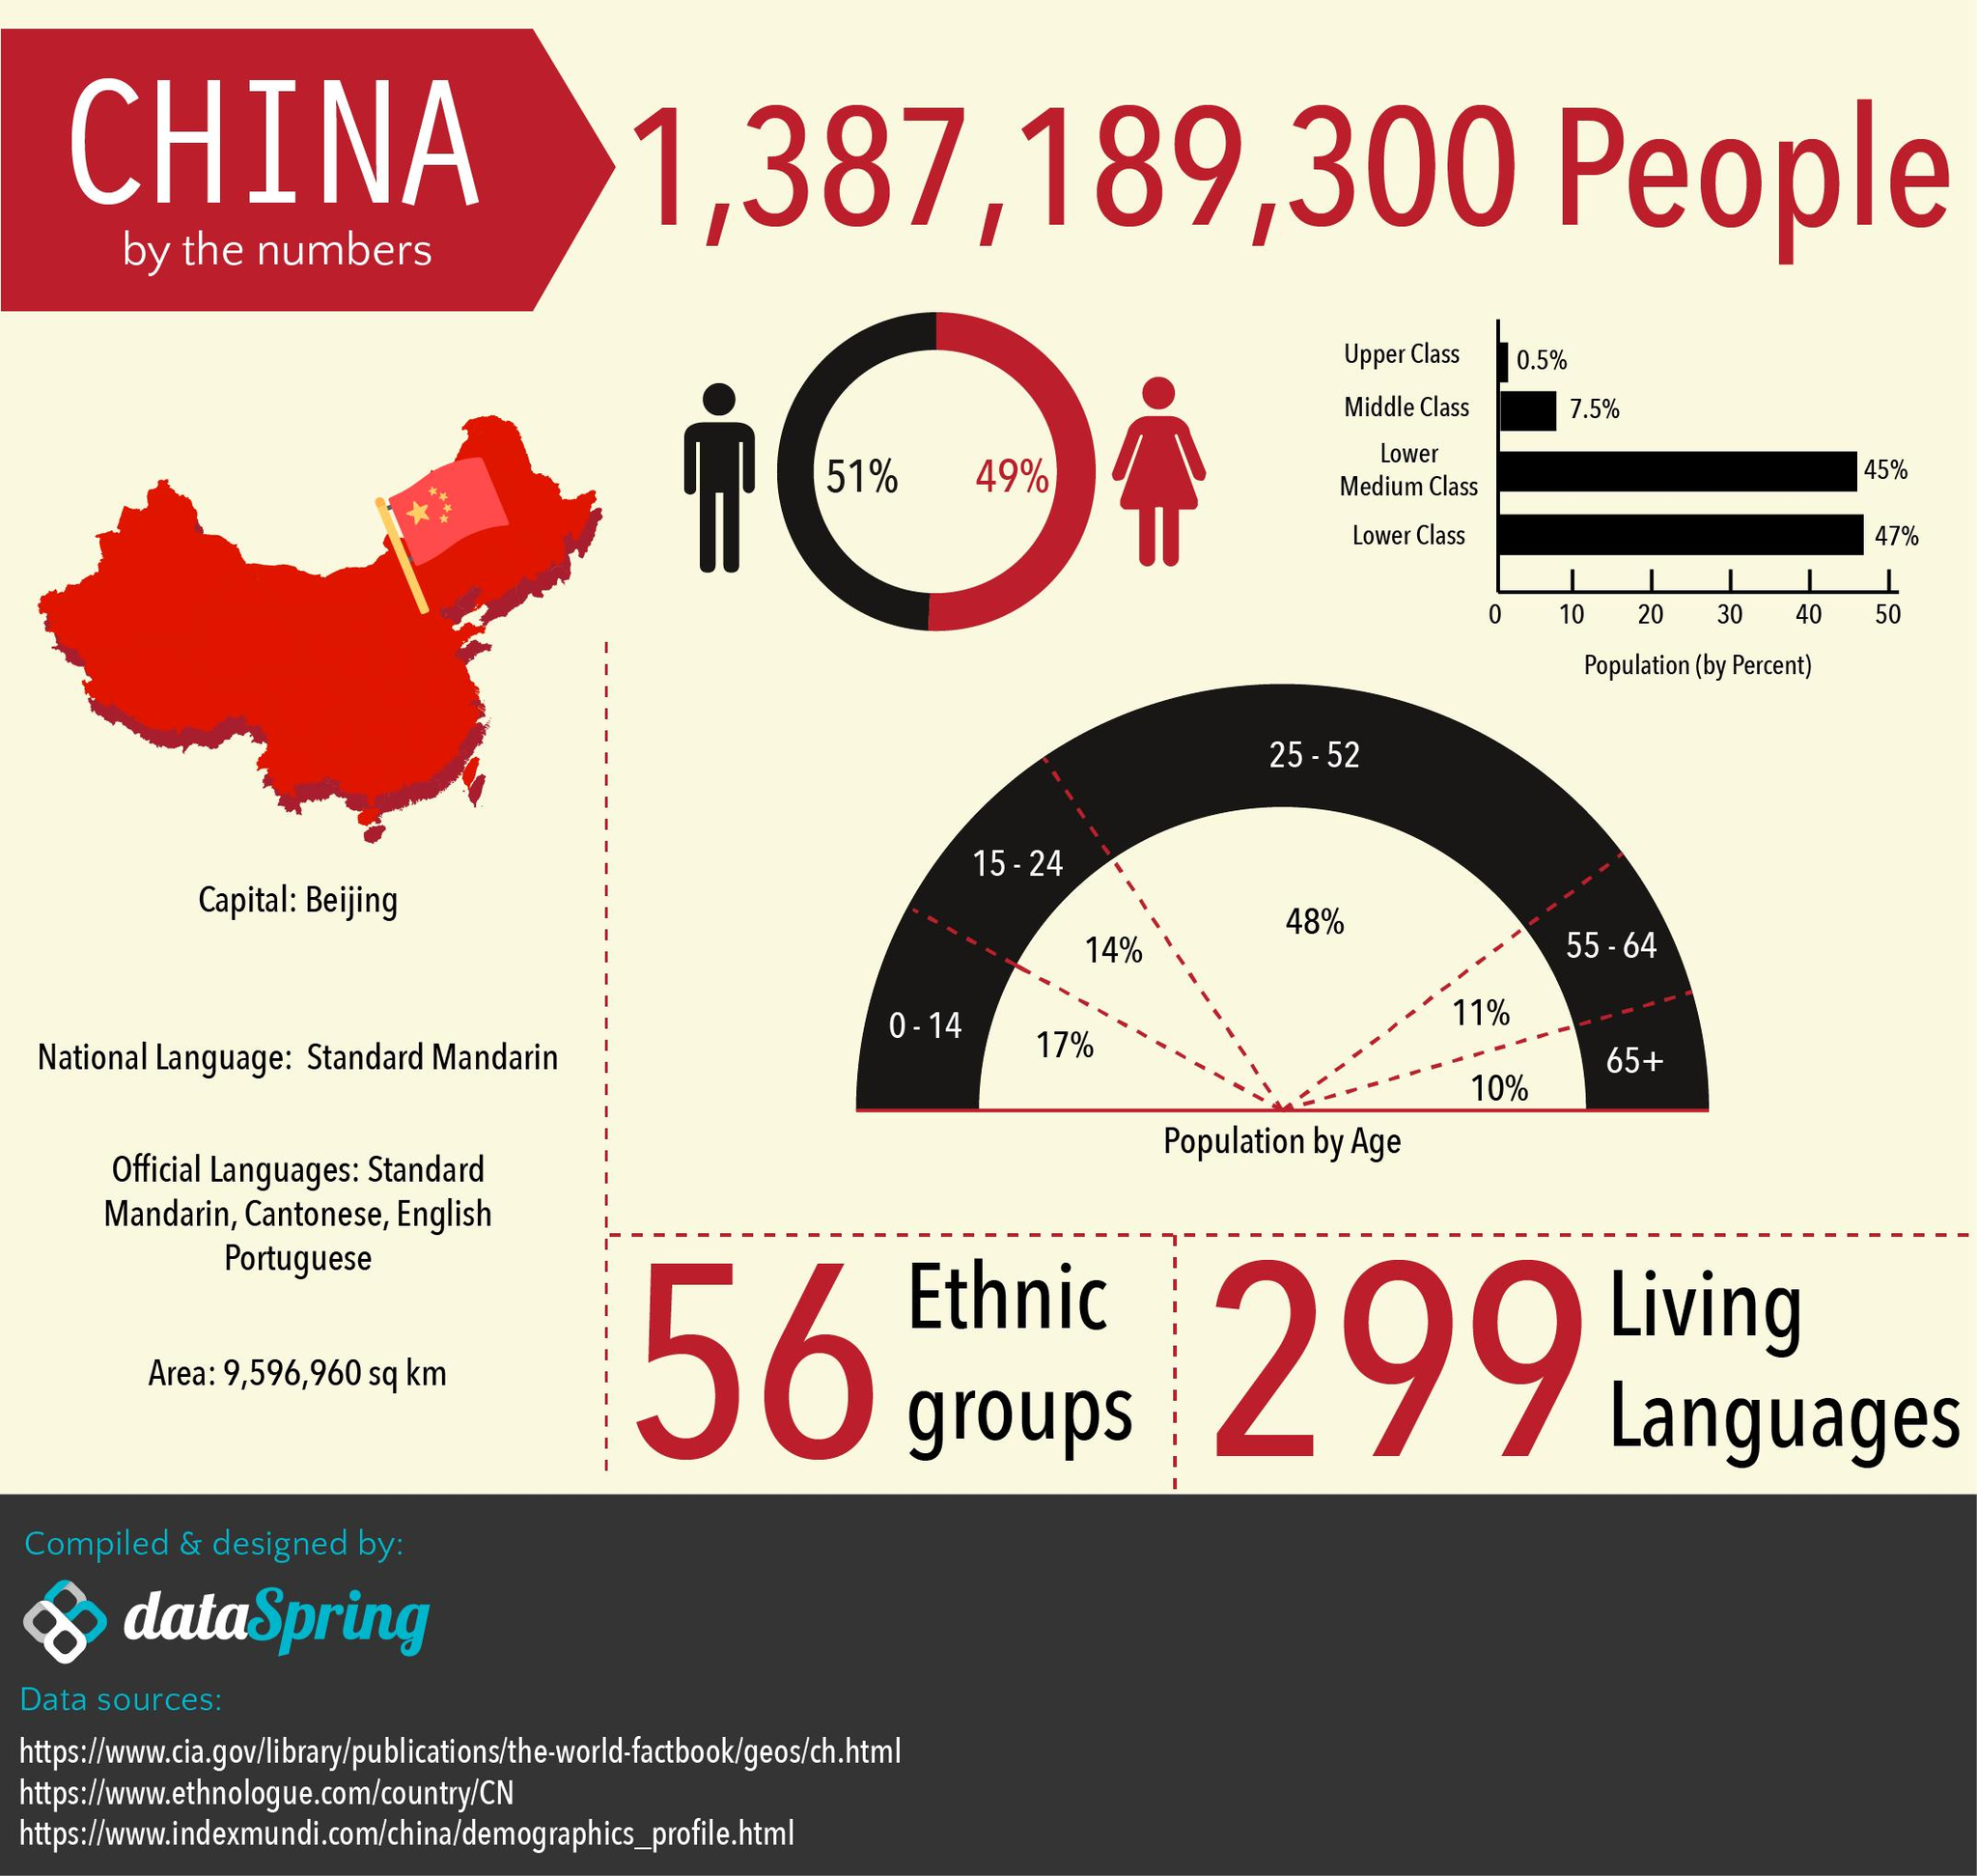Outline some significant characteristics in this image. According to recent data, males in China comprise approximately 51% of the population. A total of 31% of the population is comprised of those aged 0-14 and 15-24, taken together. China has four official languages. According to a recent survey, the combined percentage of Upper class and Middle-class people in China is approximately 8%. In China, females account for 49% of the population. 